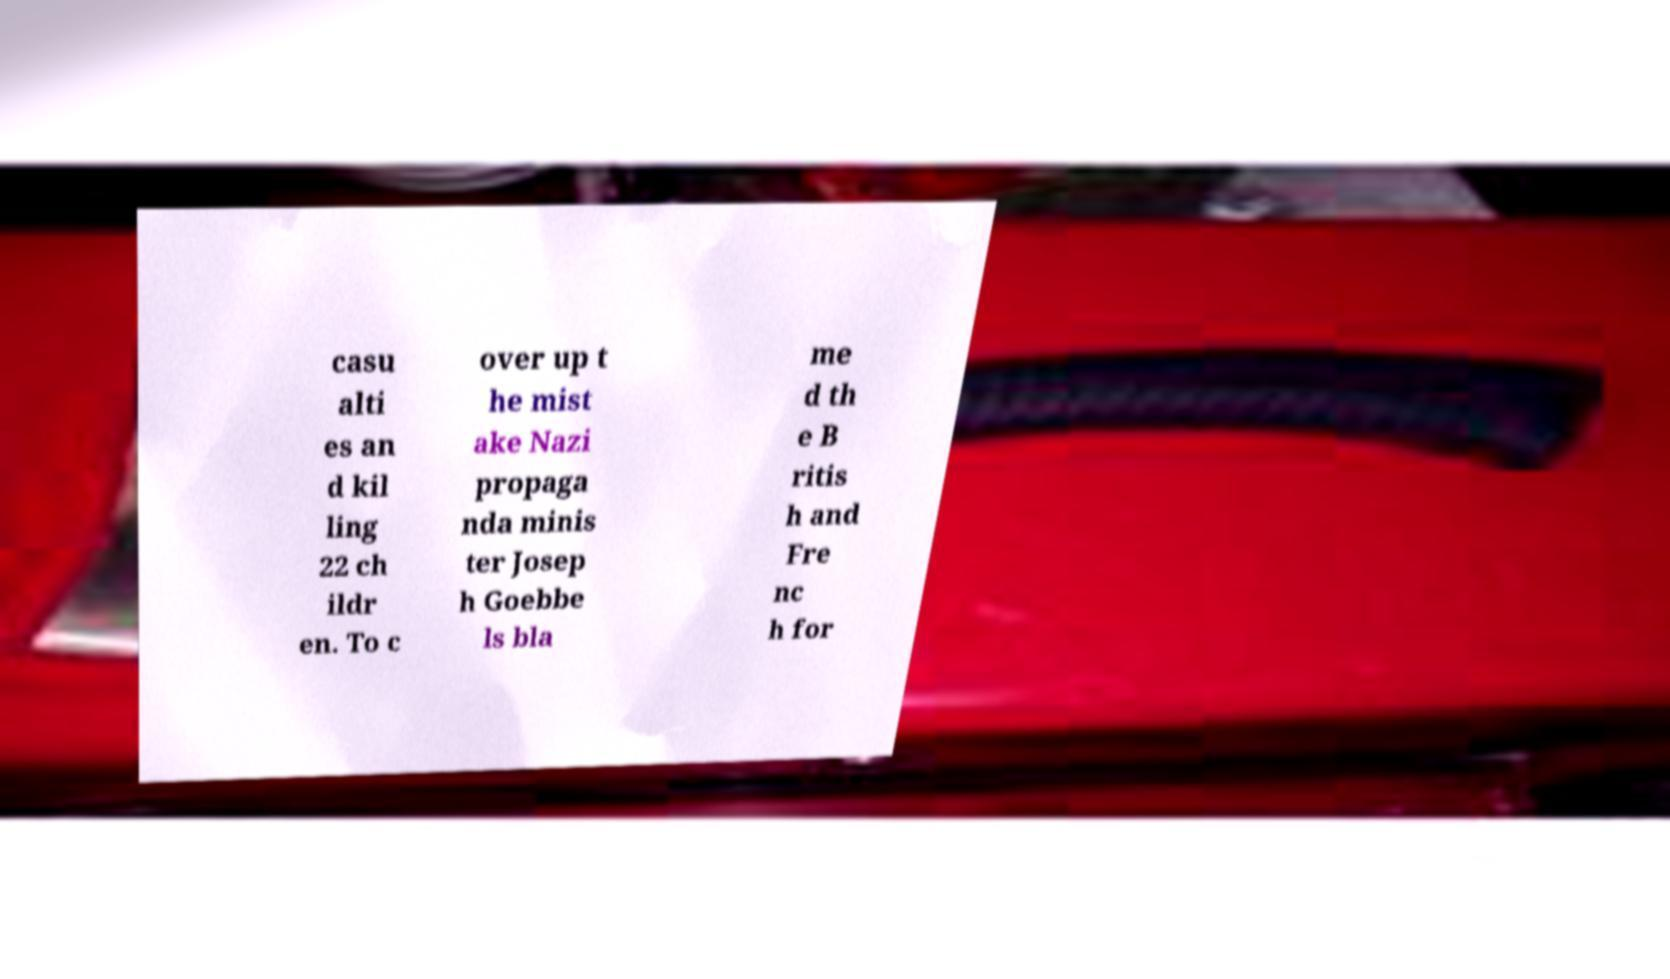Can you read and provide the text displayed in the image?This photo seems to have some interesting text. Can you extract and type it out for me? casu alti es an d kil ling 22 ch ildr en. To c over up t he mist ake Nazi propaga nda minis ter Josep h Goebbe ls bla me d th e B ritis h and Fre nc h for 